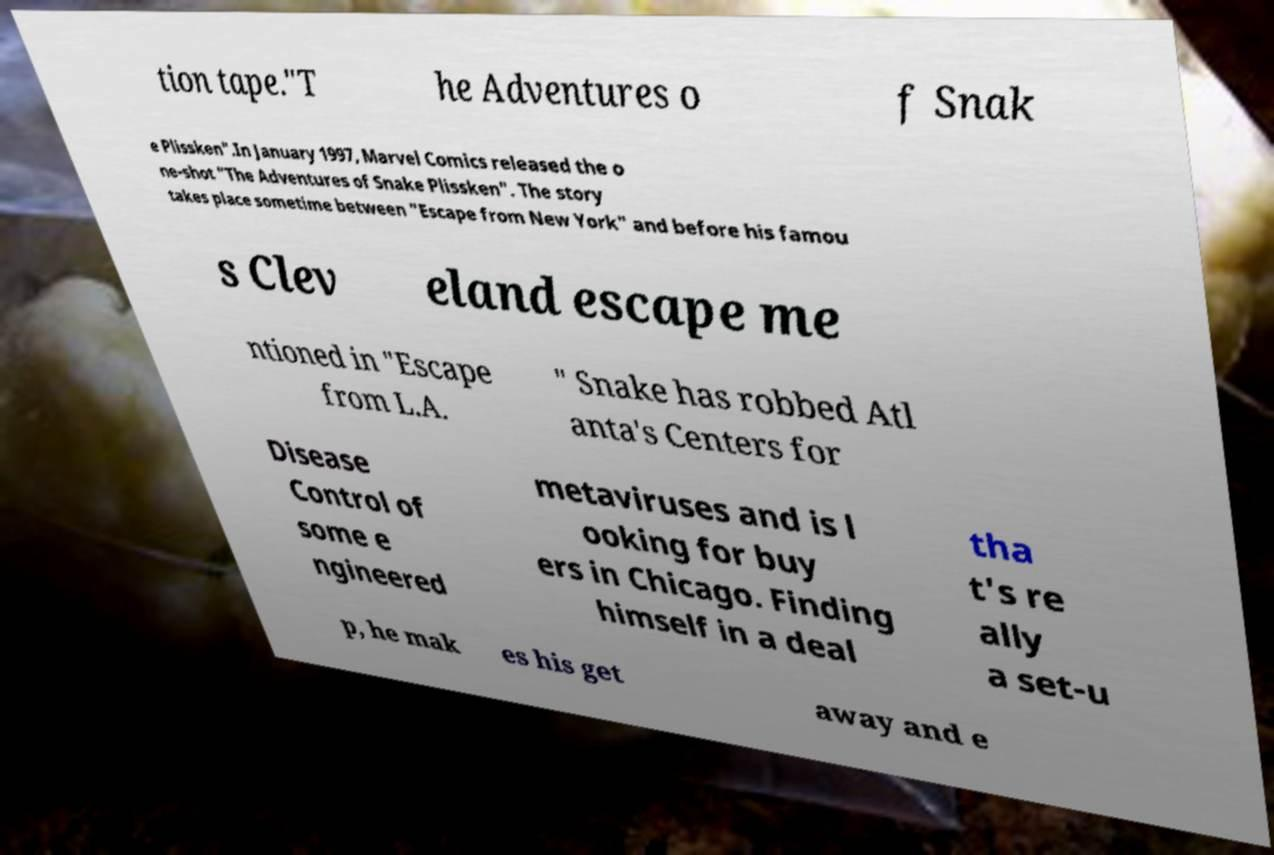Please identify and transcribe the text found in this image. tion tape."T he Adventures o f Snak e Plissken".In January 1997, Marvel Comics released the o ne-shot "The Adventures of Snake Plissken". The story takes place sometime between "Escape from New York" and before his famou s Clev eland escape me ntioned in "Escape from L.A. " Snake has robbed Atl anta's Centers for Disease Control of some e ngineered metaviruses and is l ooking for buy ers in Chicago. Finding himself in a deal tha t's re ally a set-u p, he mak es his get away and e 